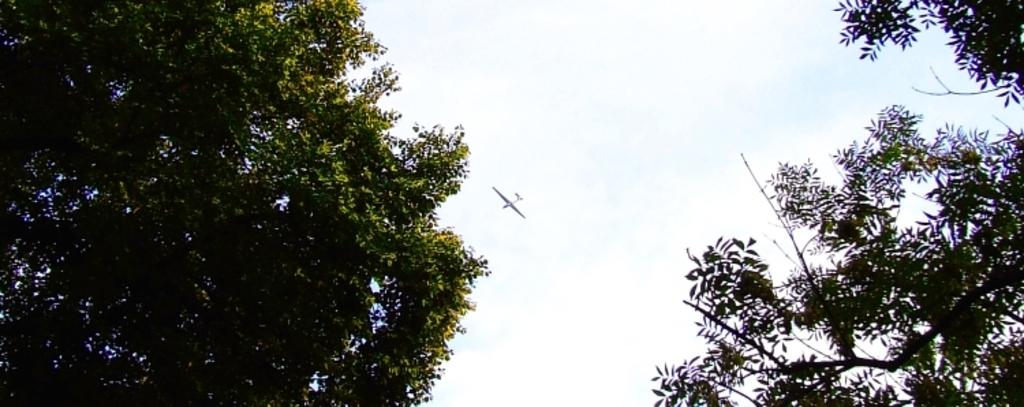What type of vegetation can be seen on both sides of the image? There are trees on the right side and the left side of the image. What is flying in the sky in the middle of the image? An airplane is flying in the sky in the middle of the image. What is visible in the background of the image? The sky is visible in the background of the image. What type of cover is being worn by the farmer in the image? There is no farmer present in the image. What is the color of the neck on the bird in the image? There are no birds present in the image. 